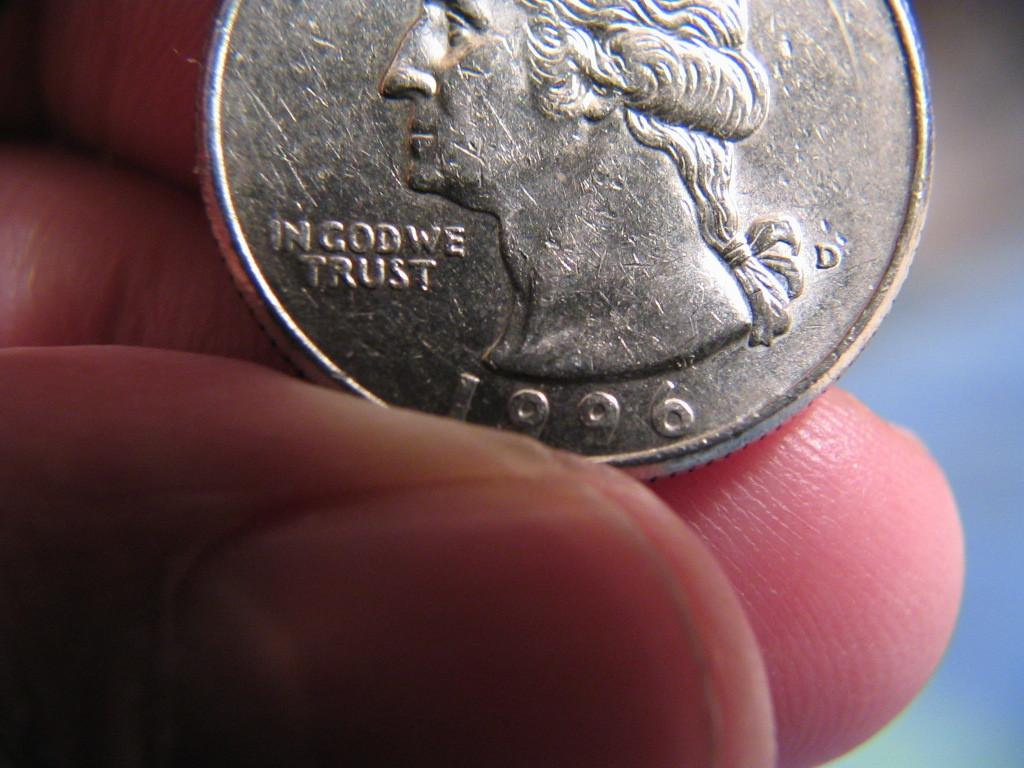<image>
Render a clear and concise summary of the photo. A person is holding a 1996 quarter that says 'In God We Trust'. 